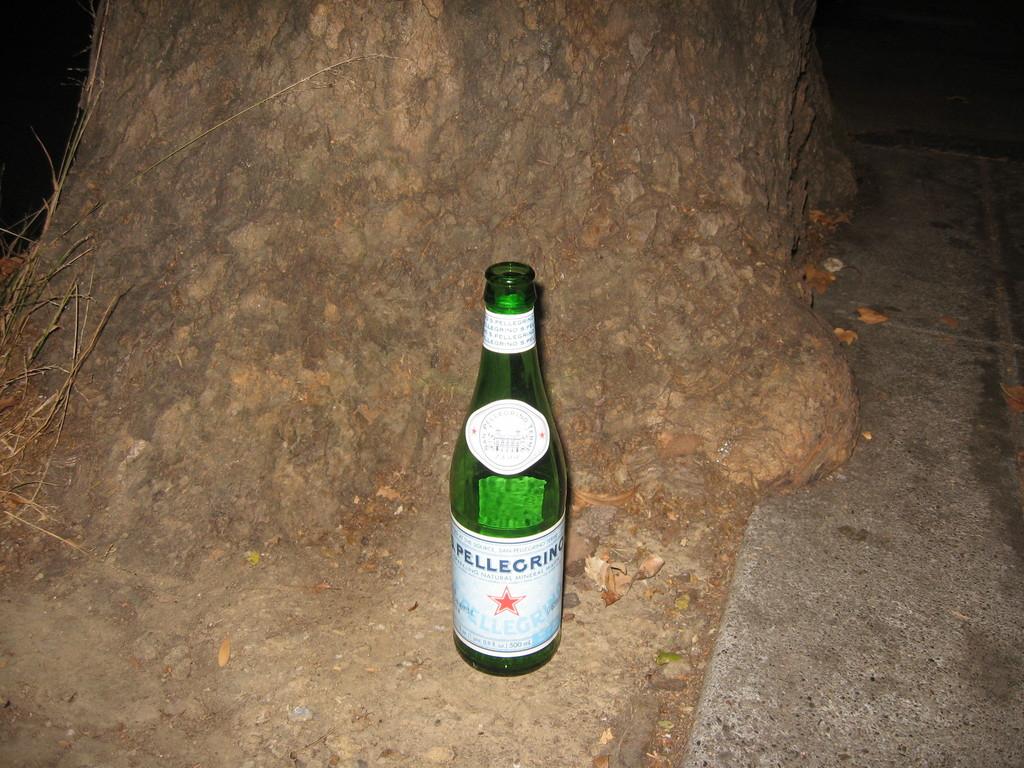What type of drink is this?
Ensure brevity in your answer.  Pellegrino. 